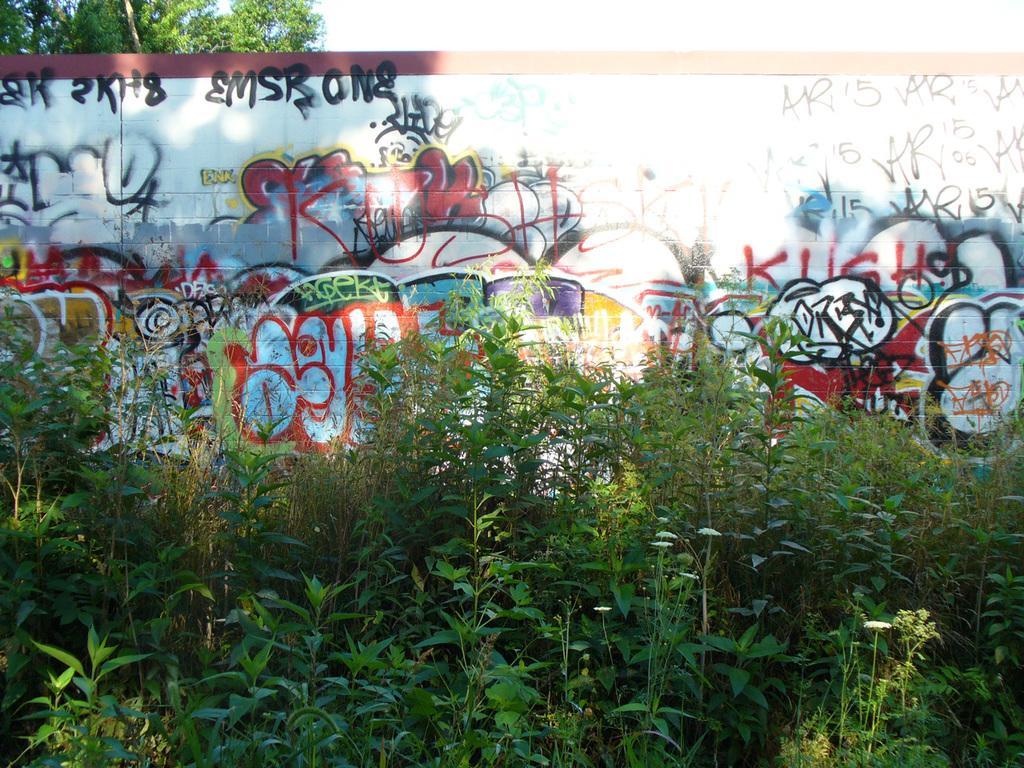Please provide a concise description of this image. In this picture we can see plants in the front, there is a wall in the middle, we can see graffiti on the wall, there is a tree at the left top of the picture. 